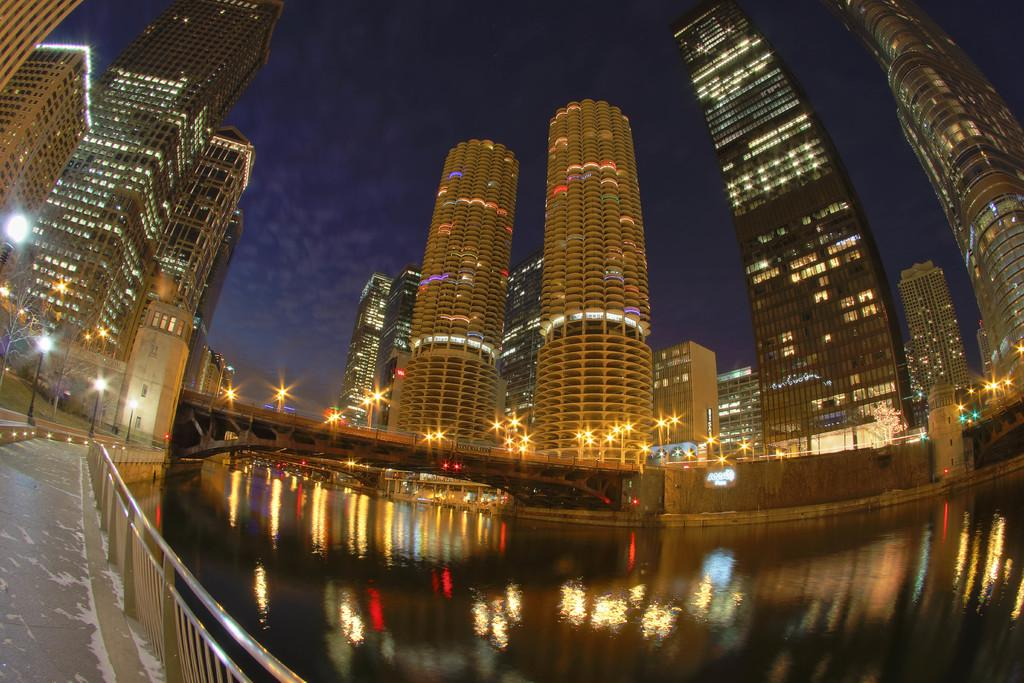What type of view is shown in the image? The image is a wide angle view. What structures can be seen in the city? There are tall towers in the city. What connects the two sides of the river? There is a bridge across the river. What is located beside the bridge? There is a footpath beside the bridge. What type of veil can be seen covering the tall towers in the image? There is no veil present in the image; the tall towers are not covered. 